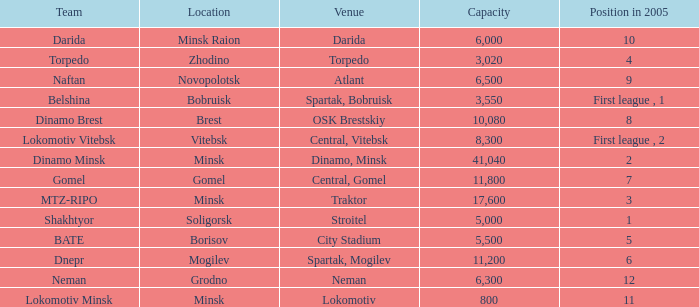Can you tell me the Venue that has the Position in 2005 of 8? OSK Brestskiy. 